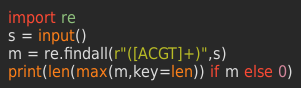Convert code to text. <code><loc_0><loc_0><loc_500><loc_500><_Python_>import re
s = input()
m = re.findall(r"([ACGT]+)",s)
print(len(max(m,key=len)) if m else 0)</code> 